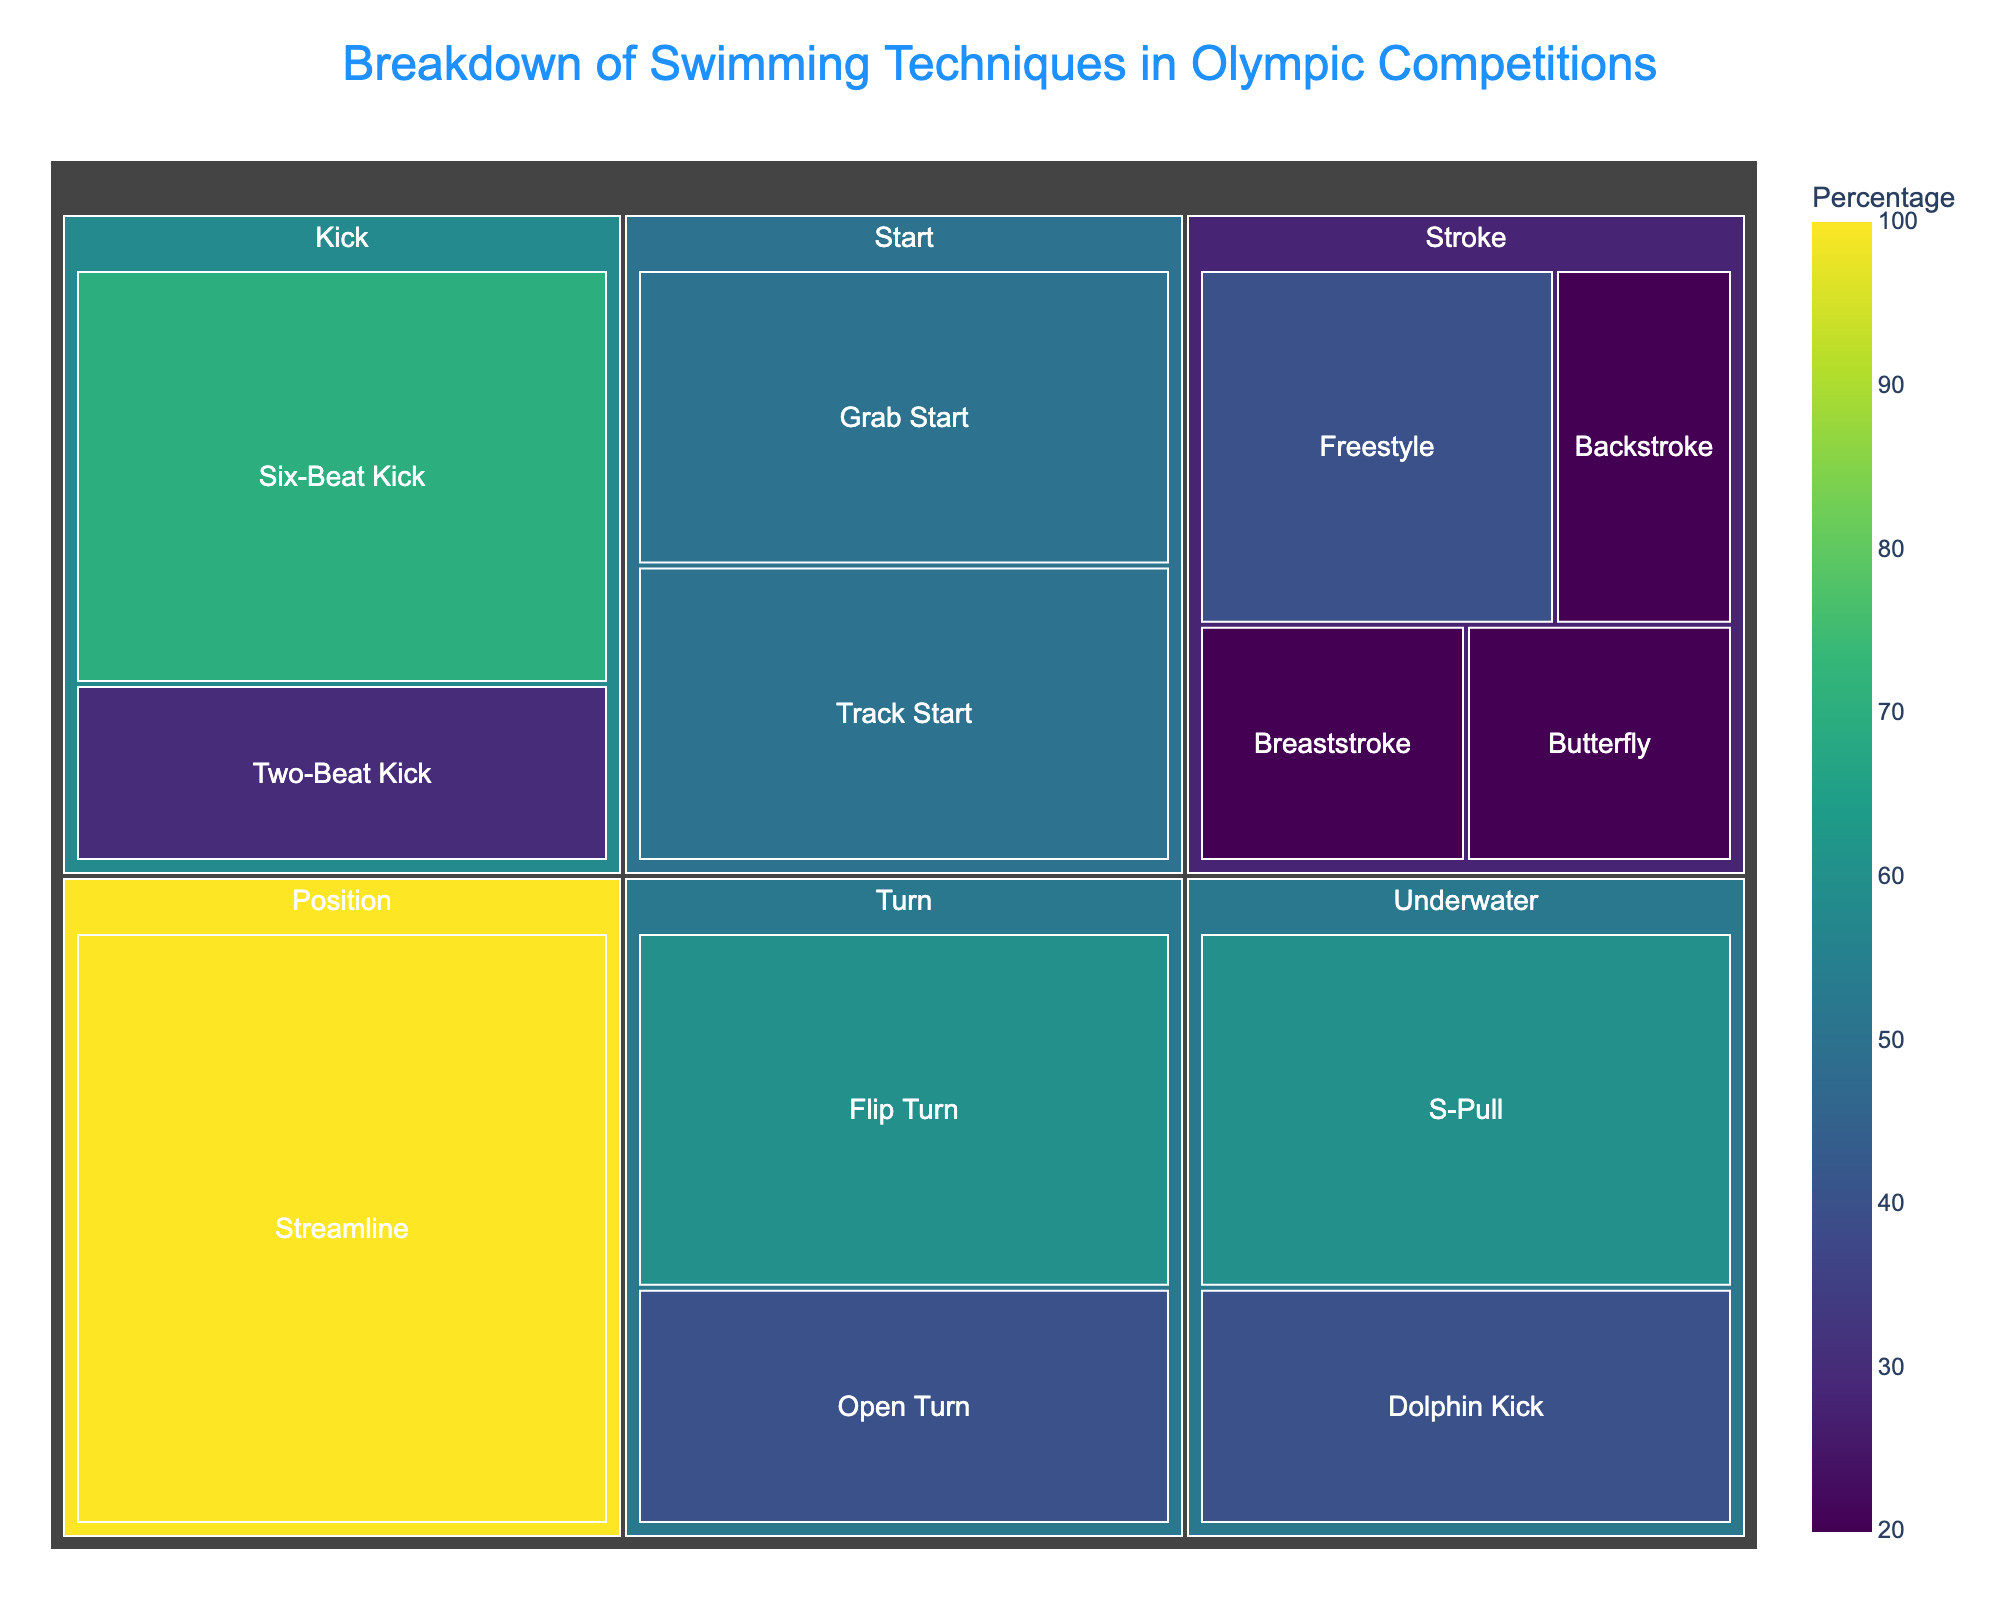What percentage of the Olympic swimming techniques belong to the 'Start' category? First, locate the 'Start' category in the figure. There are two techniques under 'Start': Grab Start and Track Start. Sum their percentages: 50% + 50% = 100%.
Answer: 100% Which swimming technique has the highest percentage used in Olympic competitions? Identify the technique with the highest percentage in the treemap. 'Flip Turn' in the 'Turn' category has the highest percentage at 60%.
Answer: Flip Turn Among the strokes, which swimming technique is used the least? Check the 'Stroke' category and compare the percentages for Freestyle, Butterfly, Backstroke, and Breaststroke. All three (Butterfly, Backstroke, and Breaststroke) have equal values of 20%, but Freestyle is the largest at 40%.
Answer: Butterfly, Backstroke, Breaststroke How does the percentage usage of the 'Two-Beat Kick' compare to the 'Six-Beat Kick'? Look into the 'Kick' category to find Two-Beat Kick at 30% and Six-Beat Kick at 70%. 'Two-Beat Kick' is lower.
Answer: Six-Beat Kick is more What is the title of the Treemap? Locate the title at the top of the treemap. It reads 'Breakdown of Swimming Techniques in Olympic Competitions'.
Answer: Breakdown of Swimming Techniques in Olympic Competitions Calculate the total percentage of techniques in the 'Underwater' category. Identify the 'Underwater' category and sum the percentages of S-Pull and Dolphin Kick: 60% + 40% = 100%.
Answer: 100% Which category has a technique with a percentage of 100%? Identify the category with a technique showing 100%. The 'Streamline' technique under 'Position' is the one.
Answer: Position Is there any category where all techniques have an equal percentage share? Scan through each category to see if the techniques have the same percentage. The 'Start' category has Grab Start and Track Start each with 50%.
Answer: Start What is the smallest percentage segment in the 'Turn' category? Look under 'Turn' and compare. Open Turn is 40%, which is smaller than Flip Turn's 60%.
Answer: Open Turn Compare the percentage of 'S-Pull' to the combined percentage of all 'Stroke' techniques. 'S-Pull' is 60%. For the 'Stroke' category, sum 40%, 20%, 20%, and 20%, which is 100%. 'S-Pull' is less than the combined strokes.
Answer: 'S-Pull' is less 